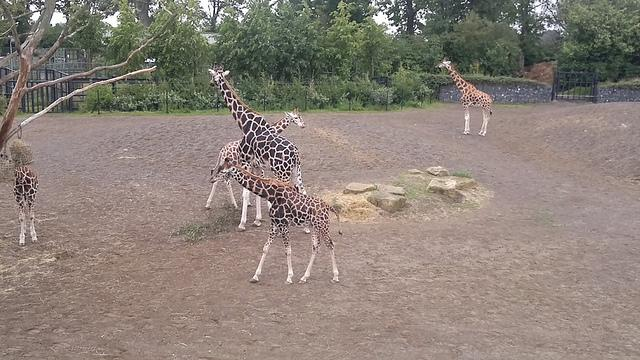What do these animals have? spots 